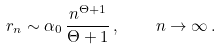<formula> <loc_0><loc_0><loc_500><loc_500>r _ { n } \sim \alpha _ { 0 } \, \frac { n ^ { \Theta + 1 } } { \Theta + 1 } \, , \quad n \to \infty \, .</formula> 